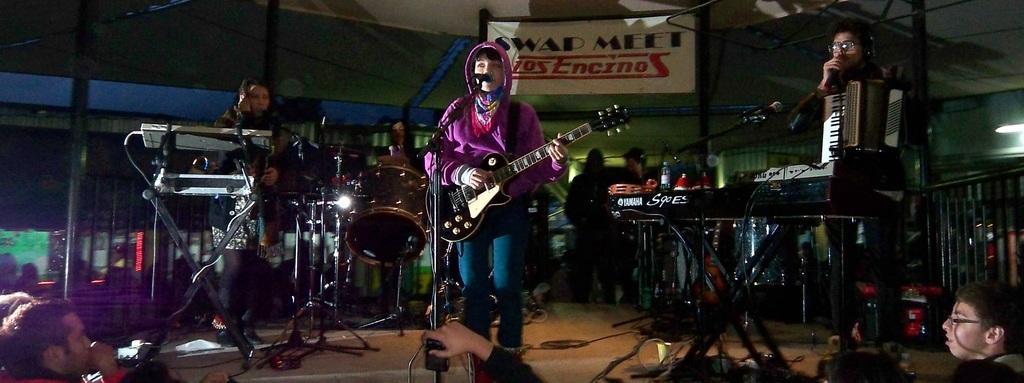Describe this image in one or two sentences. In this image I can see few people playing musical instruments on the stage. At the top there is some text. At the bottom there are few people. 